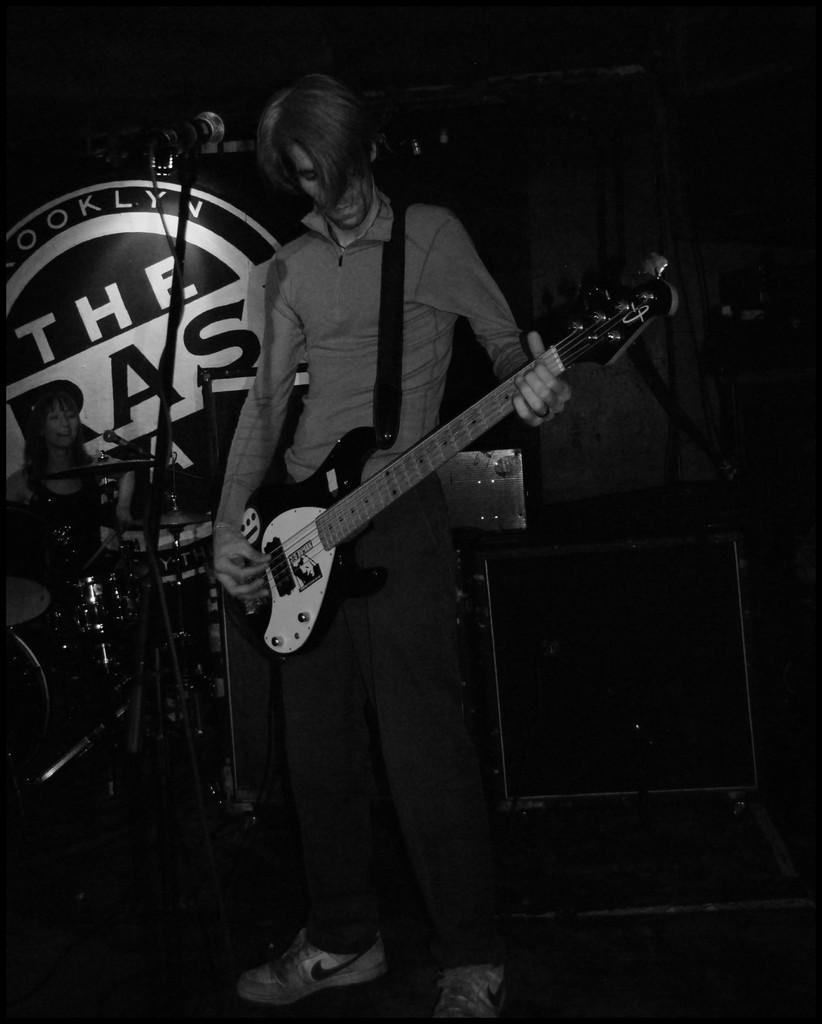In one or two sentences, can you explain what this image depicts? This picture shows a man playing a guitar and we see a microphone front of him and we see a woman seated 